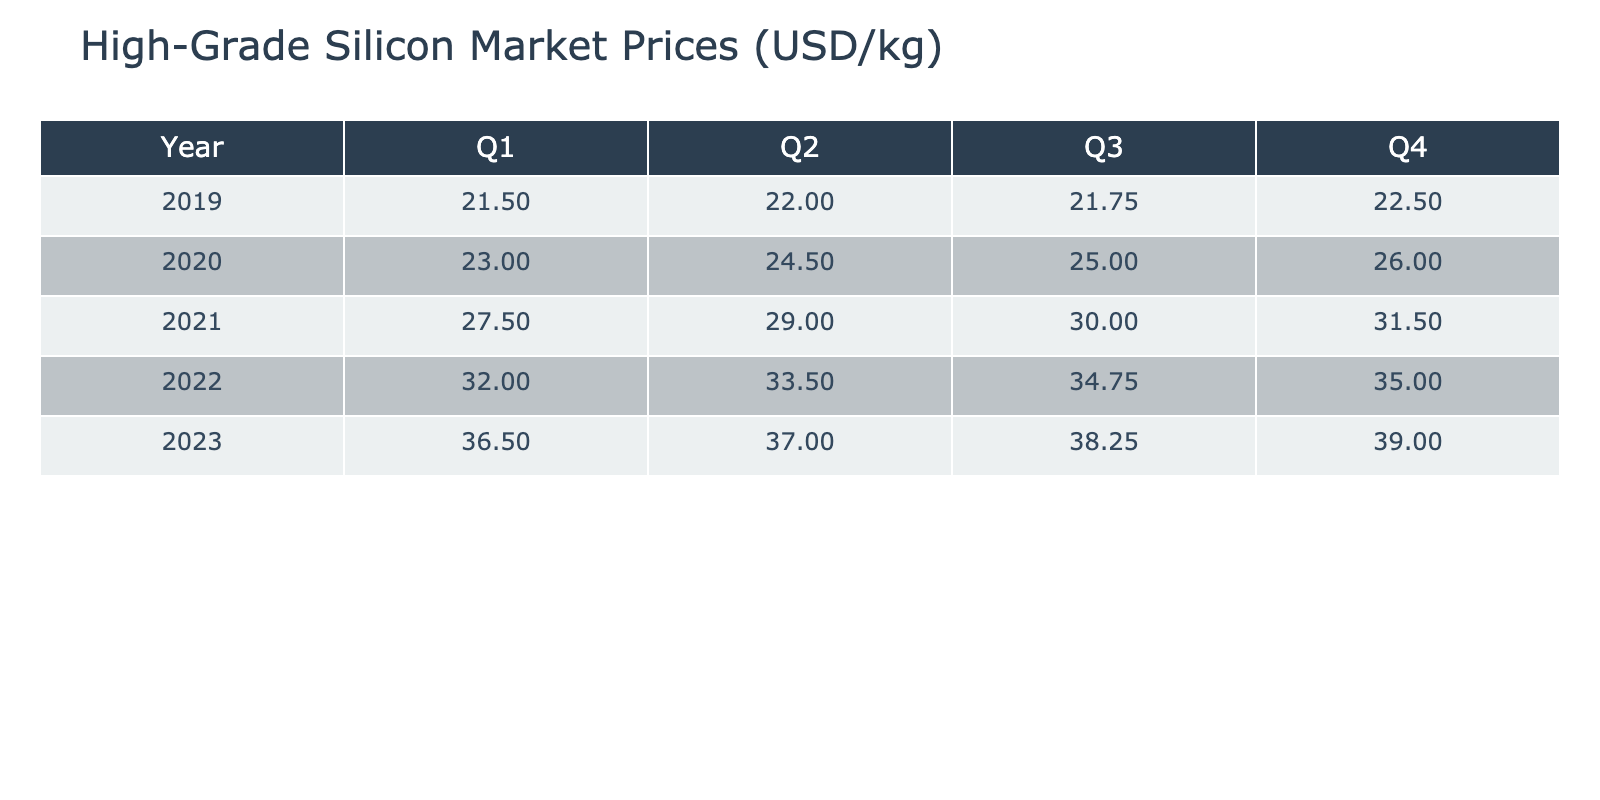What was the market price of high-grade silicon in Q4 2020? Looking in the table for year 2020 and quarter Q4, I find the market price listed as 26.00 USD/kg.
Answer: 26.00 USD/kg What is the highest market price recorded in 2021? The highest value in 2021 can be found by checking the market prices for each quarter: Q1 is 27.50, Q2 is 29.00, Q3 is 30.00, and Q4 is 31.50. The highest price here is 31.50 USD/kg in Q4.
Answer: 31.50 USD/kg What was the average market price of high-grade silicon across all quarters in 2022? The prices for 2022 are Q1: 32.00, Q2: 33.50, Q3: 34.75, Q4: 35.00. To find the average, I sum these values (32.00 + 33.50 + 34.75 + 35.00) = 135.25 and divide by 4, resulting in an average price of 33.81 USD/kg.
Answer: 33.81 USD/kg Did the market price increase every quarter from Q1 2019 to Q4 2023? Checking each quarter's prices, I see there are some fluctuations. For instance, Q1 2019 was 21.50, and it increases every quarter to Q4 2019 (22.50), continuing to rise until Q1 2021 (27.50), then continues to rise without any decrease until Q4 2023, which shows consistent increases throughout the period. Therefore, the statement is true.
Answer: Yes What is the difference in market price from Q1 2020 to Q4 2020? The market price for Q1 2020 is 23.00 and for Q4 2020 is 26.00. To find the difference, I subtract Q1 from Q4: 26.00 - 23.00 = 3.00 USD/kg.
Answer: 3.00 USD/kg What quarter in 2023 saw the highest market price? Looking at the prices for 2023, Q1 is 36.50, Q2 is 37.00, Q3 is 38.25, and Q4 is 39.00. The highest price is in Q4 at 39.00 USD/kg.
Answer: Q4 2023 What was the average price in the second quarter across all five years? The second quarters' prices for each year are: 2019 - 22.00, 2020 - 24.50, 2021 - 29.00, 2022 - 33.50, 2023 - 37.00. I sum these values (22.00 + 24.50 + 29.00 + 33.50 + 37.00) = 146.00 and divide by 5, giving an average of 29.20 USD/kg.
Answer: 29.20 USD/kg Which source provided the market price data in Q3 2021? To find this, I check the source column for the corresponding row for 2021 Q3, which indicates Reuters provided the data for this quarter.
Answer: Reuters Was the price of silicon higher in Q2 2021 than in Q2 2020? I compare the prices: Q2 2021 is 29.00 and Q2 2020 is 24.50. Since 29.00 is greater than 24.50, the statement is true.
Answer: Yes 